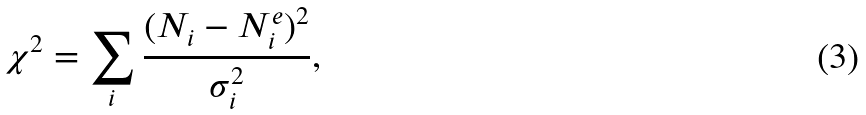<formula> <loc_0><loc_0><loc_500><loc_500>\chi ^ { 2 } = \sum _ { i } \frac { ( N _ { i } - N _ { i } ^ { e } ) ^ { 2 } } { \sigma ^ { 2 } _ { i } } ,</formula> 